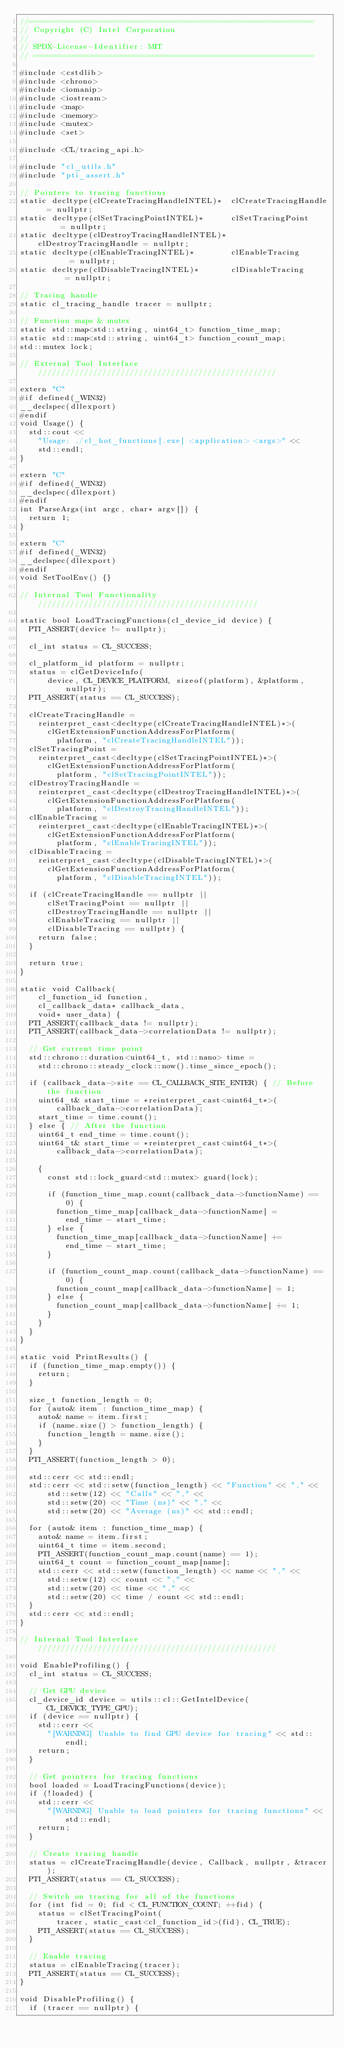Convert code to text. <code><loc_0><loc_0><loc_500><loc_500><_C++_>//==============================================================
// Copyright (C) Intel Corporation
//
// SPDX-License-Identifier: MIT
// =============================================================

#include <cstdlib>
#include <chrono>
#include <iomanip>
#include <iostream>
#include <map>
#include <memory>
#include <mutex>
#include <set>

#include <CL/tracing_api.h>

#include "cl_utils.h"
#include "pti_assert.h"

// Pointers to tracing functions
static decltype(clCreateTracingHandleINTEL)*  clCreateTracingHandle  = nullptr;
static decltype(clSetTracingPointINTEL)*      clSetTracingPoint      = nullptr;
static decltype(clDestroyTracingHandleINTEL)* clDestroyTracingHandle = nullptr;
static decltype(clEnableTracingINTEL)*        clEnableTracing        = nullptr;
static decltype(clDisableTracingINTEL)*       clDisableTracing       = nullptr;

// Tracing handle
static cl_tracing_handle tracer = nullptr;

// Function maps & mutex
static std::map<std::string, uint64_t> function_time_map;
static std::map<std::string, uint64_t> function_count_map;
std::mutex lock;

// External Tool Interface ////////////////////////////////////////////////////

extern "C"
#if defined(_WIN32)
__declspec(dllexport)
#endif
void Usage() {
  std::cout <<
    "Usage: ./cl_hot_functions[.exe] <application> <args>" <<
    std::endl;
}

extern "C"
#if defined(_WIN32)
__declspec(dllexport)
#endif
int ParseArgs(int argc, char* argv[]) {
  return 1;
}

extern "C"
#if defined(_WIN32)
__declspec(dllexport)
#endif
void SetToolEnv() {}

// Internal Tool Functionality ////////////////////////////////////////////////

static bool LoadTracingFunctions(cl_device_id device) {
  PTI_ASSERT(device != nullptr);

  cl_int status = CL_SUCCESS;

  cl_platform_id platform = nullptr;
  status = clGetDeviceInfo(
      device, CL_DEVICE_PLATFORM, sizeof(platform), &platform, nullptr);
  PTI_ASSERT(status == CL_SUCCESS);

  clCreateTracingHandle =
    reinterpret_cast<decltype(clCreateTracingHandleINTEL)*>(
      clGetExtensionFunctionAddressForPlatform(
        platform, "clCreateTracingHandleINTEL"));
  clSetTracingPoint =
    reinterpret_cast<decltype(clSetTracingPointINTEL)*>(
      clGetExtensionFunctionAddressForPlatform(
        platform, "clSetTracingPointINTEL"));
  clDestroyTracingHandle =
    reinterpret_cast<decltype(clDestroyTracingHandleINTEL)*>(
      clGetExtensionFunctionAddressForPlatform(
        platform, "clDestroyTracingHandleINTEL"));
  clEnableTracing =
    reinterpret_cast<decltype(clEnableTracingINTEL)*>(
      clGetExtensionFunctionAddressForPlatform(
        platform, "clEnableTracingINTEL"));
  clDisableTracing =
    reinterpret_cast<decltype(clDisableTracingINTEL)*>(
      clGetExtensionFunctionAddressForPlatform(
        platform, "clDisableTracingINTEL"));

  if (clCreateTracingHandle == nullptr ||
      clSetTracingPoint == nullptr ||
      clDestroyTracingHandle == nullptr ||
      clEnableTracing == nullptr ||
      clDisableTracing == nullptr) {
    return false;
  }

  return true;
}

static void Callback(
    cl_function_id function,
    cl_callback_data* callback_data,
    void* user_data) {
  PTI_ASSERT(callback_data != nullptr);
  PTI_ASSERT(callback_data->correlationData != nullptr);

  // Get current time point
  std::chrono::duration<uint64_t, std::nano> time =
    std::chrono::steady_clock::now().time_since_epoch();

  if (callback_data->site == CL_CALLBACK_SITE_ENTER) { // Before the function
    uint64_t& start_time = *reinterpret_cast<uint64_t*>(
        callback_data->correlationData);
    start_time = time.count();
  } else { // After the function
    uint64_t end_time = time.count();
    uint64_t& start_time = *reinterpret_cast<uint64_t*>(
        callback_data->correlationData);

    {
      const std::lock_guard<std::mutex> guard(lock);

      if (function_time_map.count(callback_data->functionName) == 0) {
        function_time_map[callback_data->functionName] =
          end_time - start_time;
      } else {
        function_time_map[callback_data->functionName] +=
          end_time - start_time;
      }

      if (function_count_map.count(callback_data->functionName) == 0) {
        function_count_map[callback_data->functionName] = 1;
      } else {
        function_count_map[callback_data->functionName] += 1;
      }
    }
  }
}

static void PrintResults() {
  if (function_time_map.empty()) {
    return;
  }

  size_t function_length = 0;
  for (auto& item : function_time_map) {
    auto& name = item.first;
    if (name.size() > function_length) {
      function_length = name.size();
    }
  }
  PTI_ASSERT(function_length > 0);

  std::cerr << std::endl;
  std::cerr << std::setw(function_length) << "Function" << "," <<
      std::setw(12) << "Calls" << "," <<
      std::setw(20) << "Time (ns)" << "," <<
      std::setw(20) << "Average (ns)" << std::endl;

  for (auto& item : function_time_map) {
    auto& name = item.first;
    uint64_t time = item.second;
    PTI_ASSERT(function_count_map.count(name) == 1);
    uint64_t count = function_count_map[name];
    std::cerr << std::setw(function_length) << name << "," <<
      std::setw(12) << count << "," <<
      std::setw(20) << time << "," <<
      std::setw(20) << time / count << std::endl;
  }
  std::cerr << std::endl;
}

// Internal Tool Interface ////////////////////////////////////////////////////

void EnableProfiling() {
  cl_int status = CL_SUCCESS;

  // Get GPU device
  cl_device_id device = utils::cl::GetIntelDevice(CL_DEVICE_TYPE_GPU);
  if (device == nullptr) {
    std::cerr <<
      "[WARNING] Unable to find GPU device for tracing" << std::endl;
    return;
  }

  // Get pointers for tracing functions
  bool loaded = LoadTracingFunctions(device);
  if (!loaded) {
    std::cerr <<
      "[WARNING] Unable to load pointers for tracing functions" << std::endl;
    return;
  }

  // Create tracing handle
  status = clCreateTracingHandle(device, Callback, nullptr, &tracer);
  PTI_ASSERT(status == CL_SUCCESS);

  // Switch on tracing for all of the functions
  for (int fid = 0; fid < CL_FUNCTION_COUNT; ++fid) {
    status = clSetTracingPoint(
        tracer, static_cast<cl_function_id>(fid), CL_TRUE);
    PTI_ASSERT(status == CL_SUCCESS);
  }

  // Enable tracing
  status = clEnableTracing(tracer);
  PTI_ASSERT(status == CL_SUCCESS);
}

void DisableProfiling() {
  if (tracer == nullptr) {</code> 